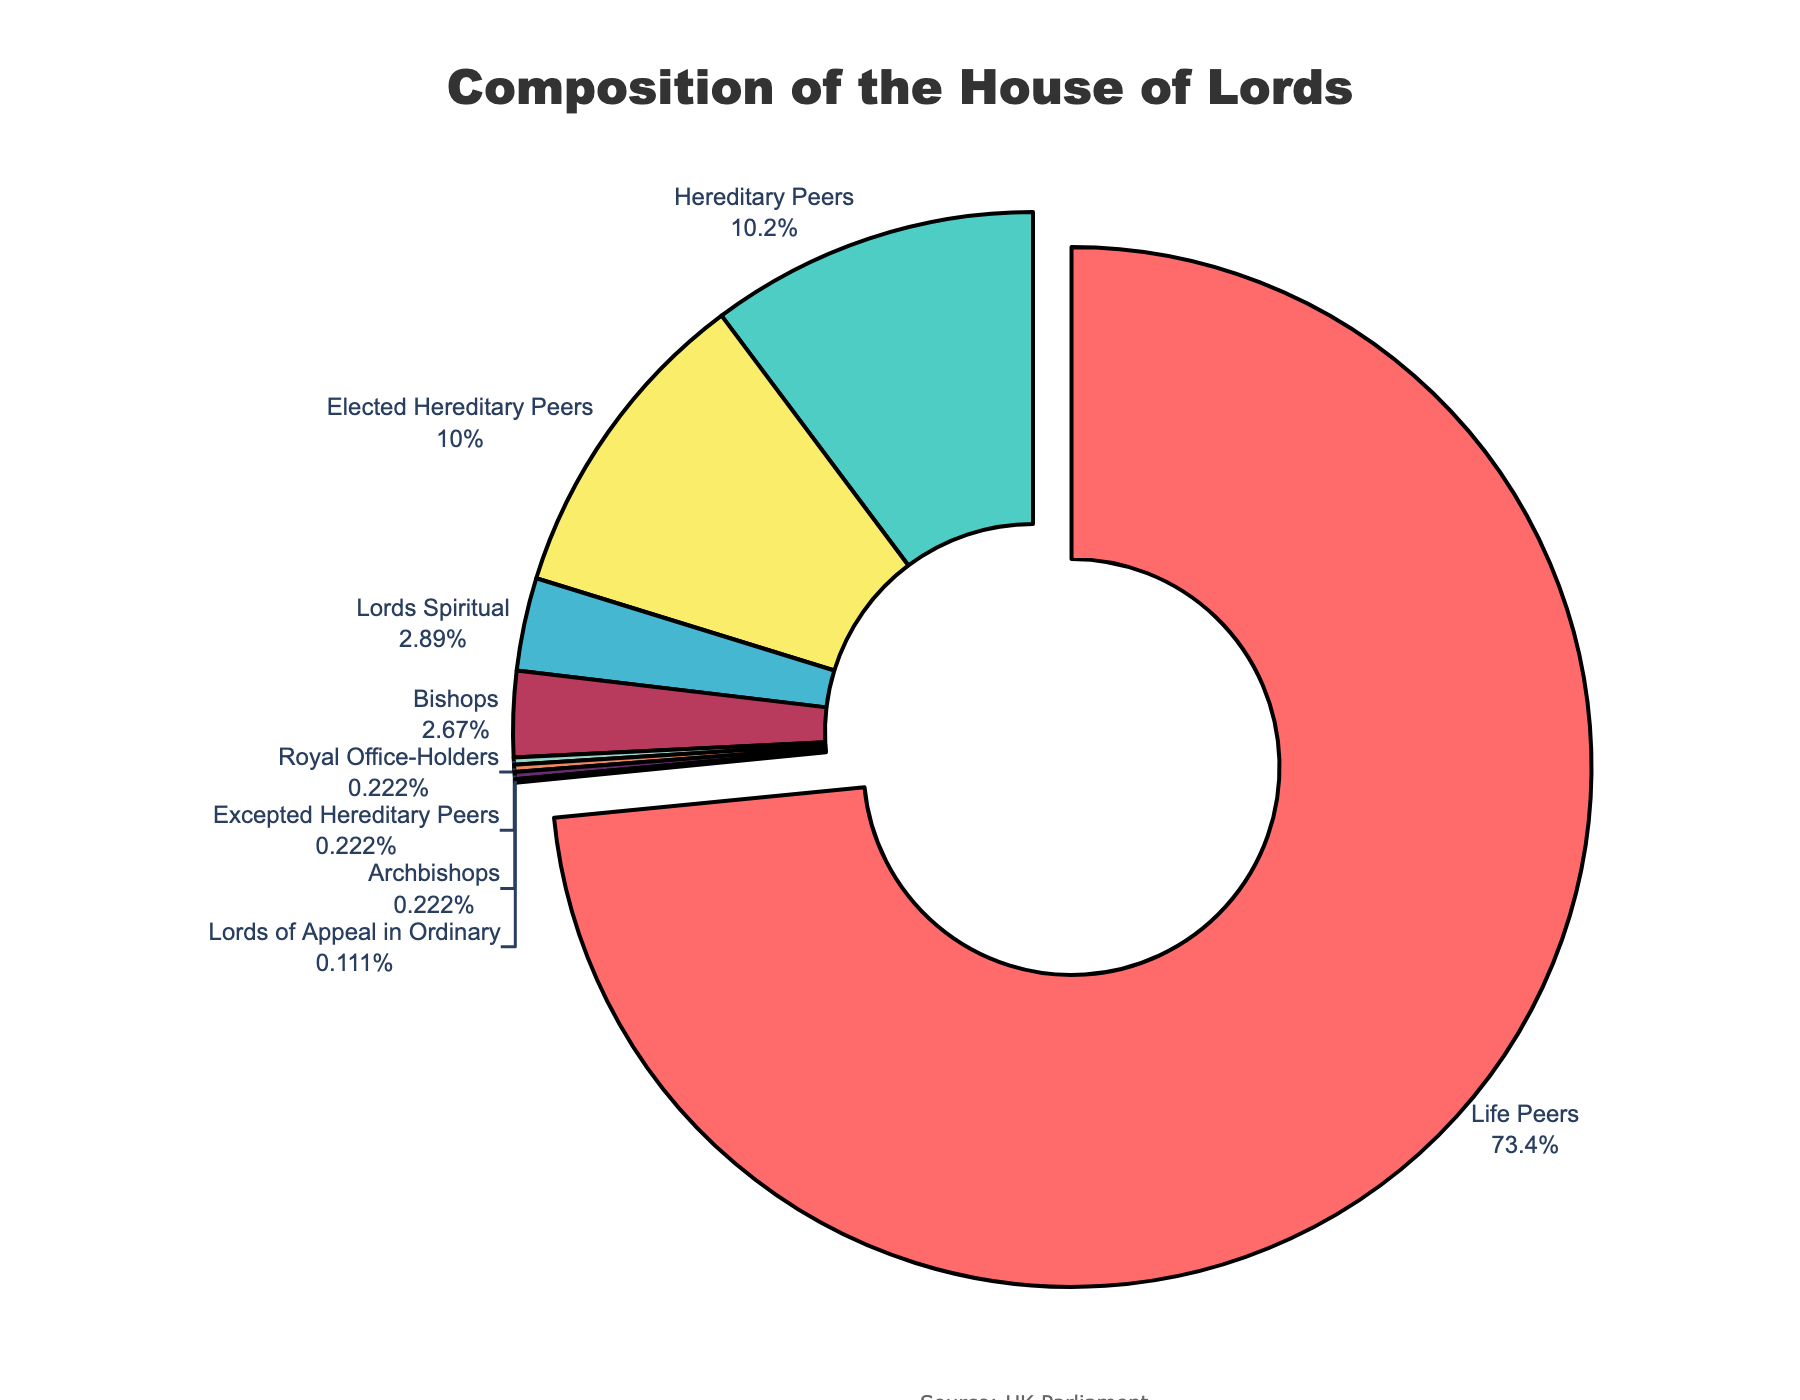What is the percentage of Life Peers in the House of Lords? From the pie chart, Life Peers represent the largest proportion. The percentage can be seen on the chart next to the label "Life Peers."
Answer: Approximately 81.45% Which peerage type is visually highlighted by being slightly pulled out from the pie chart? The segment representing the largest value in the pie chart is pulled out, which corresponds to Life Peers.
Answer: Life Peers How many more Life Peers are there than Hereditary Peers? According to the chart, Life Peers are 661, and Hereditary Peers (summing Hereditary Peers and Elected Hereditary Peers) are 92 + 90 = 182. The difference is 661 - 182 = 479.
Answer: 479 Among the categories, which has the least representation, and how many members are there in that category? Inspect the pie chart for the smallest segment, which is "Lords of Appeal in Ordinary." There is only 1 member in that category.
Answer: Lords of Appeal in Ordinary, 1 member What is the total number of Hereditary Peers, combining all related sub-categories? Combine the numbers for Hereditary Peers, Elected Hereditary Peers, and Excepted Hereditary Peers: 92 + 90 + 2 = 184.
Answer: 184 How does the number of Bishops compare to the number of Lords Spiritual? Bishops count as 24, while Lords Spiritual count as 26, so there are 2 fewer Bishops than Lords Spiritual.
Answer: 2 fewer Bishops What is the combined total of Royal Office-Holders and Archbishops in the House of Lords? Add the numbers for Royal Office-Holders and Archbishops: 2 + 2 = 4.
Answer: 4 